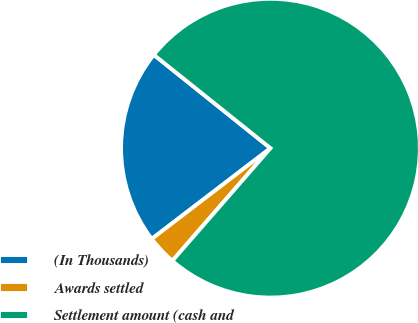Convert chart. <chart><loc_0><loc_0><loc_500><loc_500><pie_chart><fcel>(In Thousands)<fcel>Awards settled<fcel>Settlement amount (cash and<nl><fcel>21.13%<fcel>3.21%<fcel>75.66%<nl></chart> 